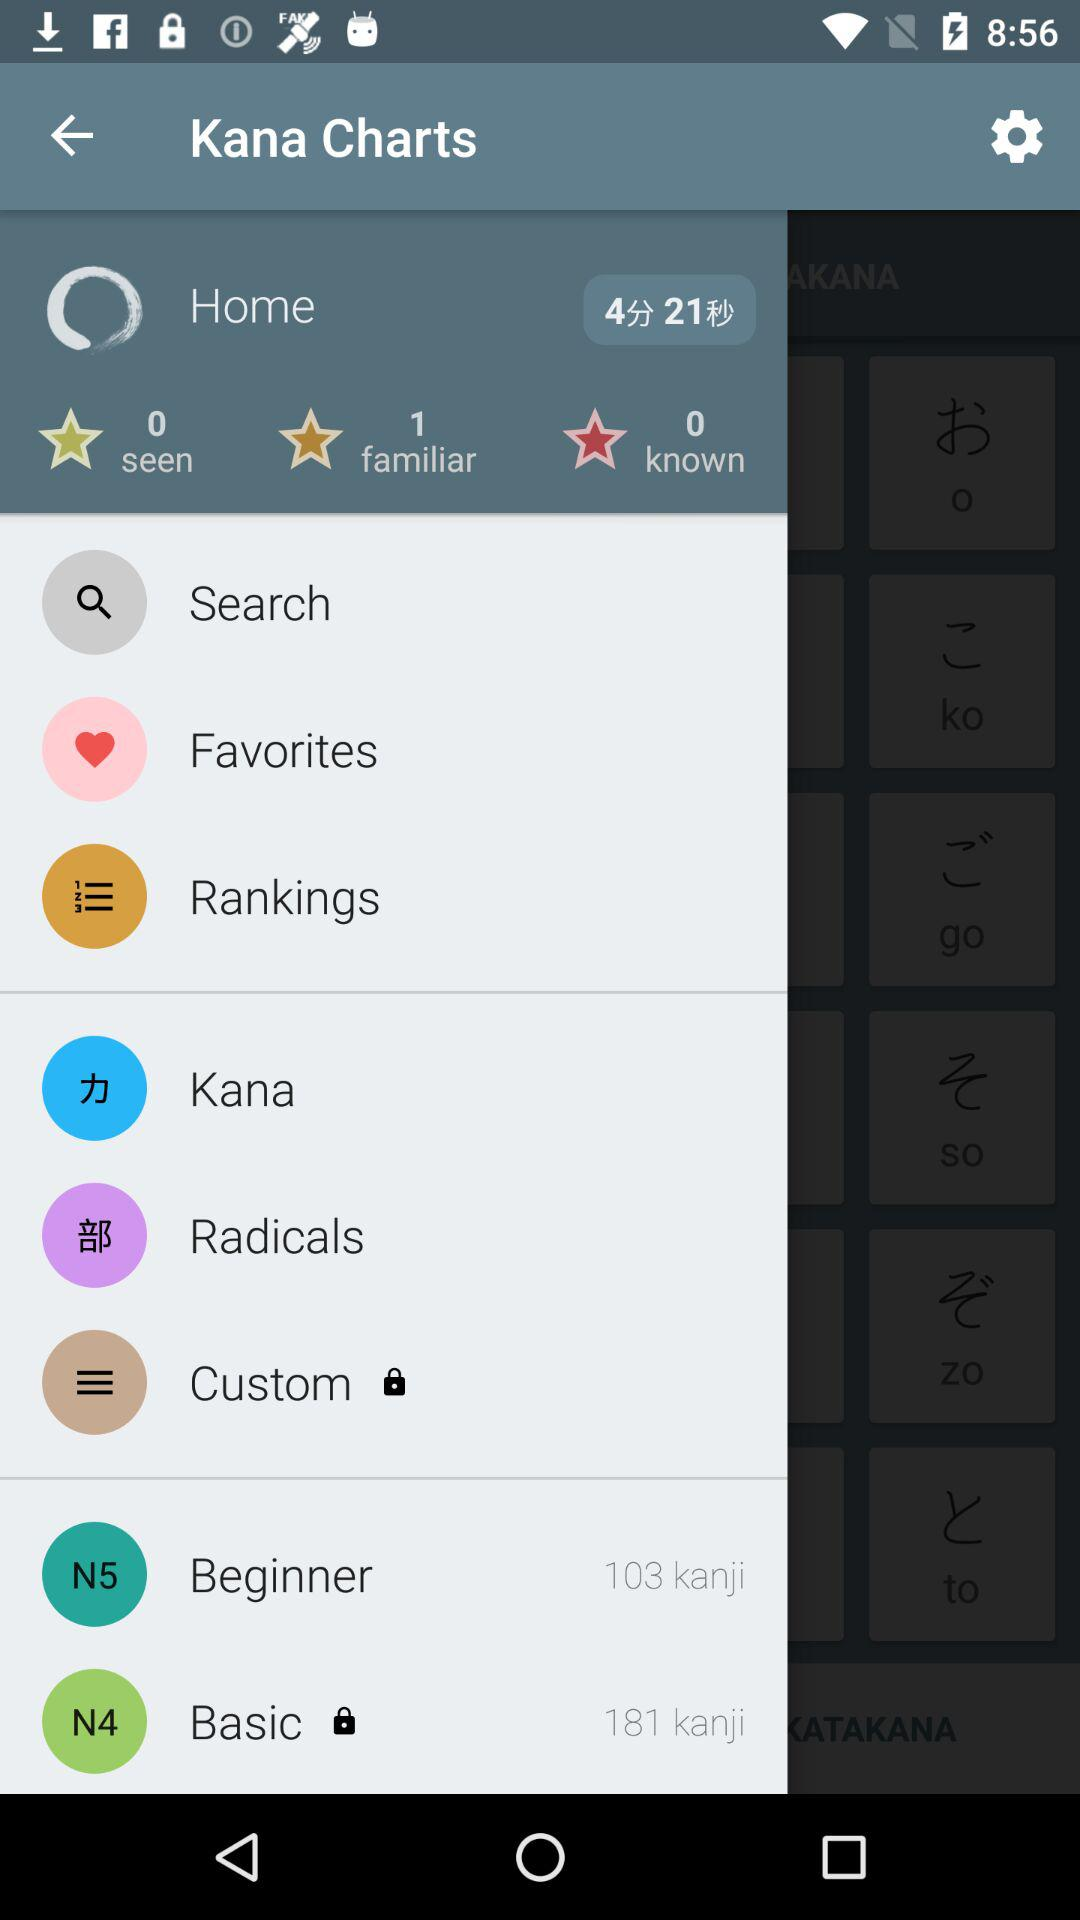How many "seen" are there? There are 0 seen. 